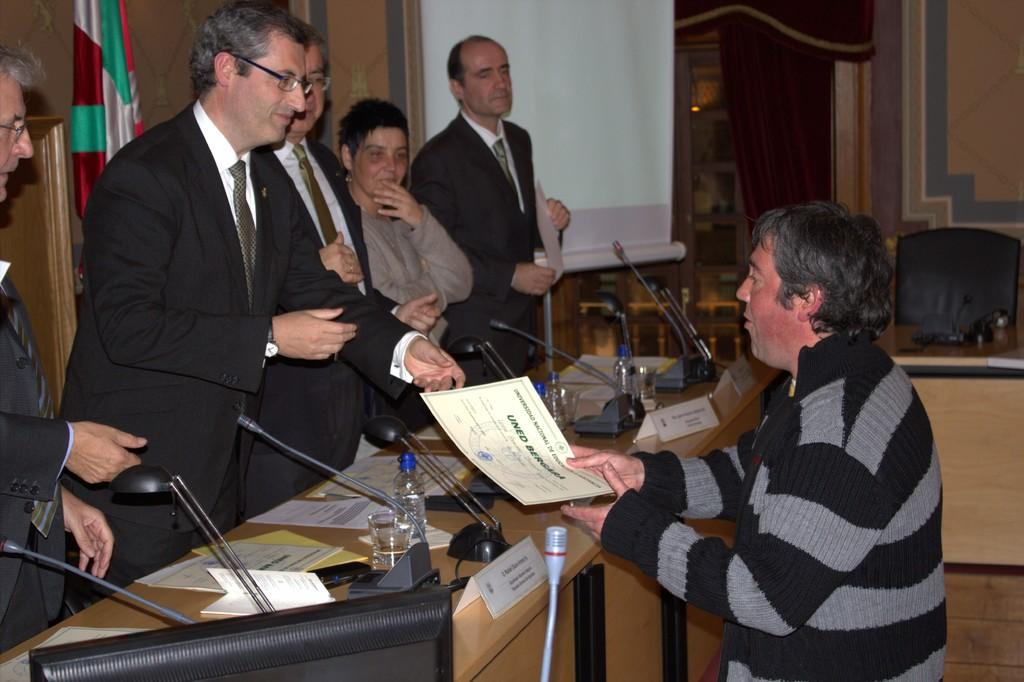<image>
Offer a succinct explanation of the picture presented. A man is holding a certificate with the word UNED on it in green print. 